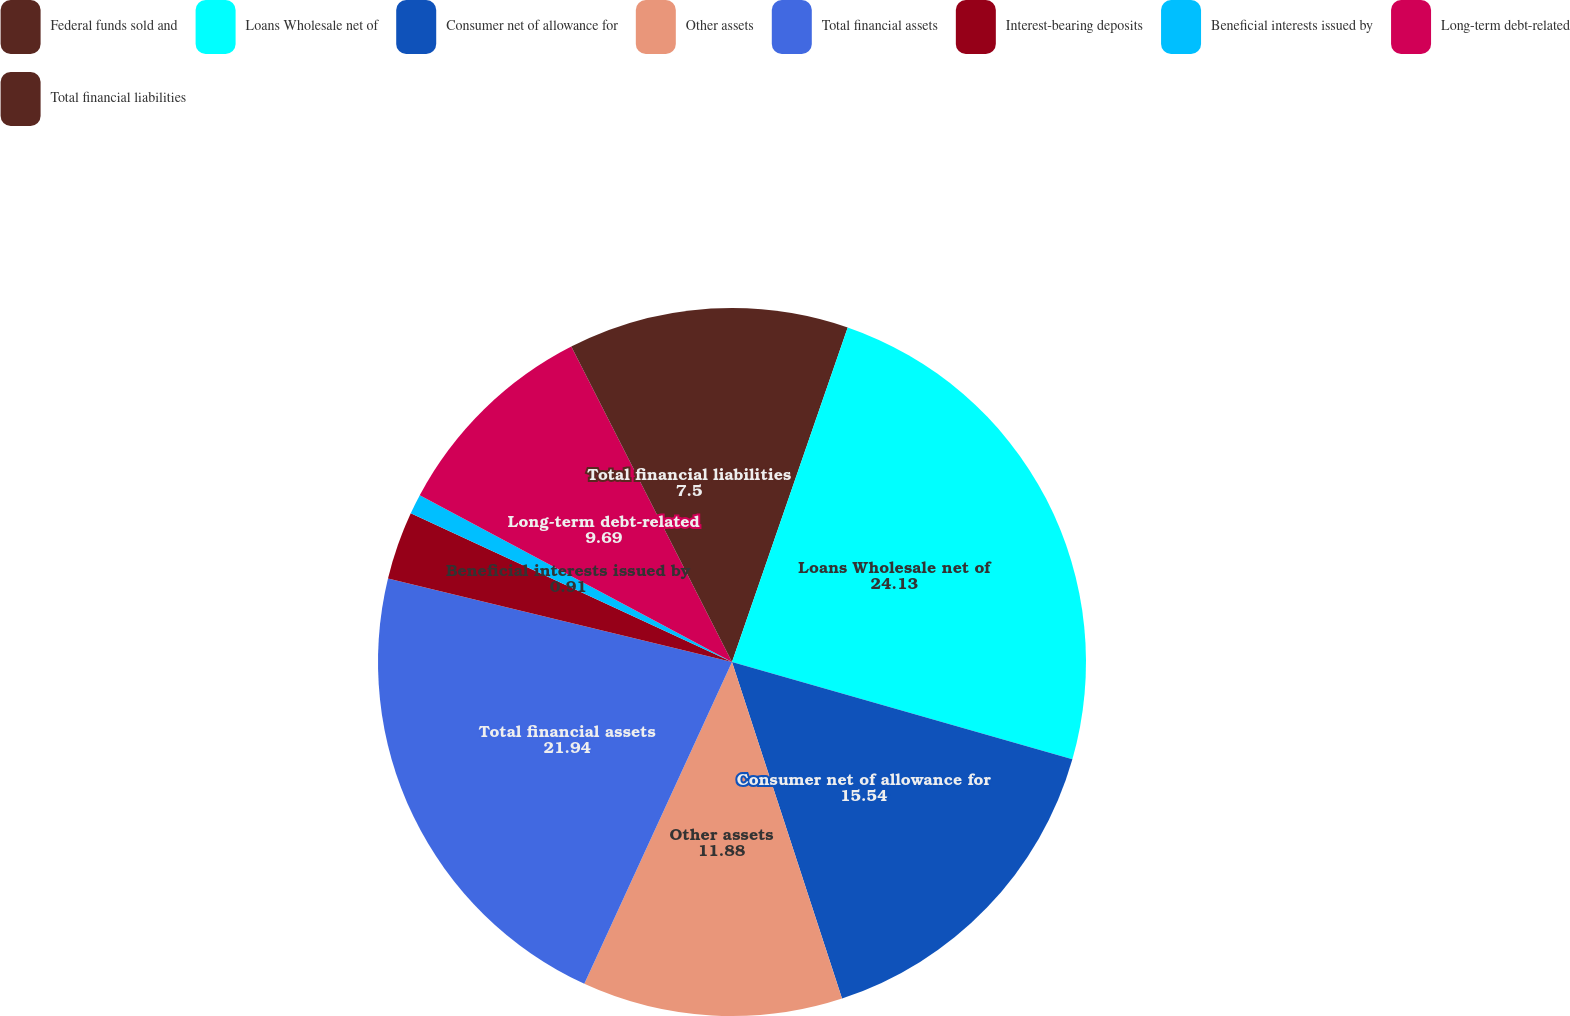<chart> <loc_0><loc_0><loc_500><loc_500><pie_chart><fcel>Federal funds sold and<fcel>Loans Wholesale net of<fcel>Consumer net of allowance for<fcel>Other assets<fcel>Total financial assets<fcel>Interest-bearing deposits<fcel>Beneficial interests issued by<fcel>Long-term debt-related<fcel>Total financial liabilities<nl><fcel>5.3%<fcel>24.13%<fcel>15.54%<fcel>11.88%<fcel>21.94%<fcel>3.11%<fcel>0.91%<fcel>9.69%<fcel>7.5%<nl></chart> 